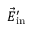Convert formula to latex. <formula><loc_0><loc_0><loc_500><loc_500>\vec { E } _ { i n } ^ { \prime }</formula> 